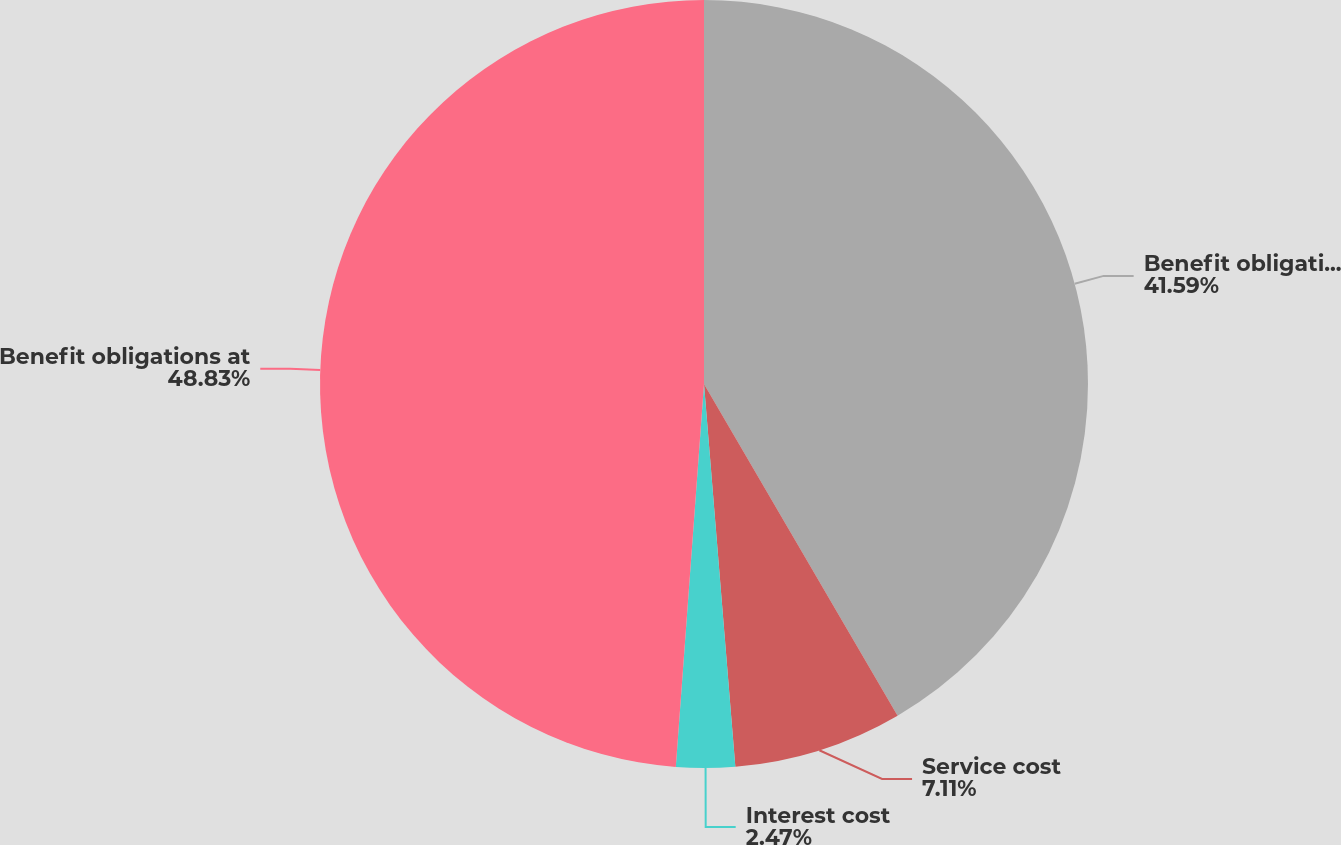Convert chart. <chart><loc_0><loc_0><loc_500><loc_500><pie_chart><fcel>Benefit obligations at January<fcel>Service cost<fcel>Interest cost<fcel>Benefit obligations at<nl><fcel>41.59%<fcel>7.11%<fcel>2.47%<fcel>48.83%<nl></chart> 